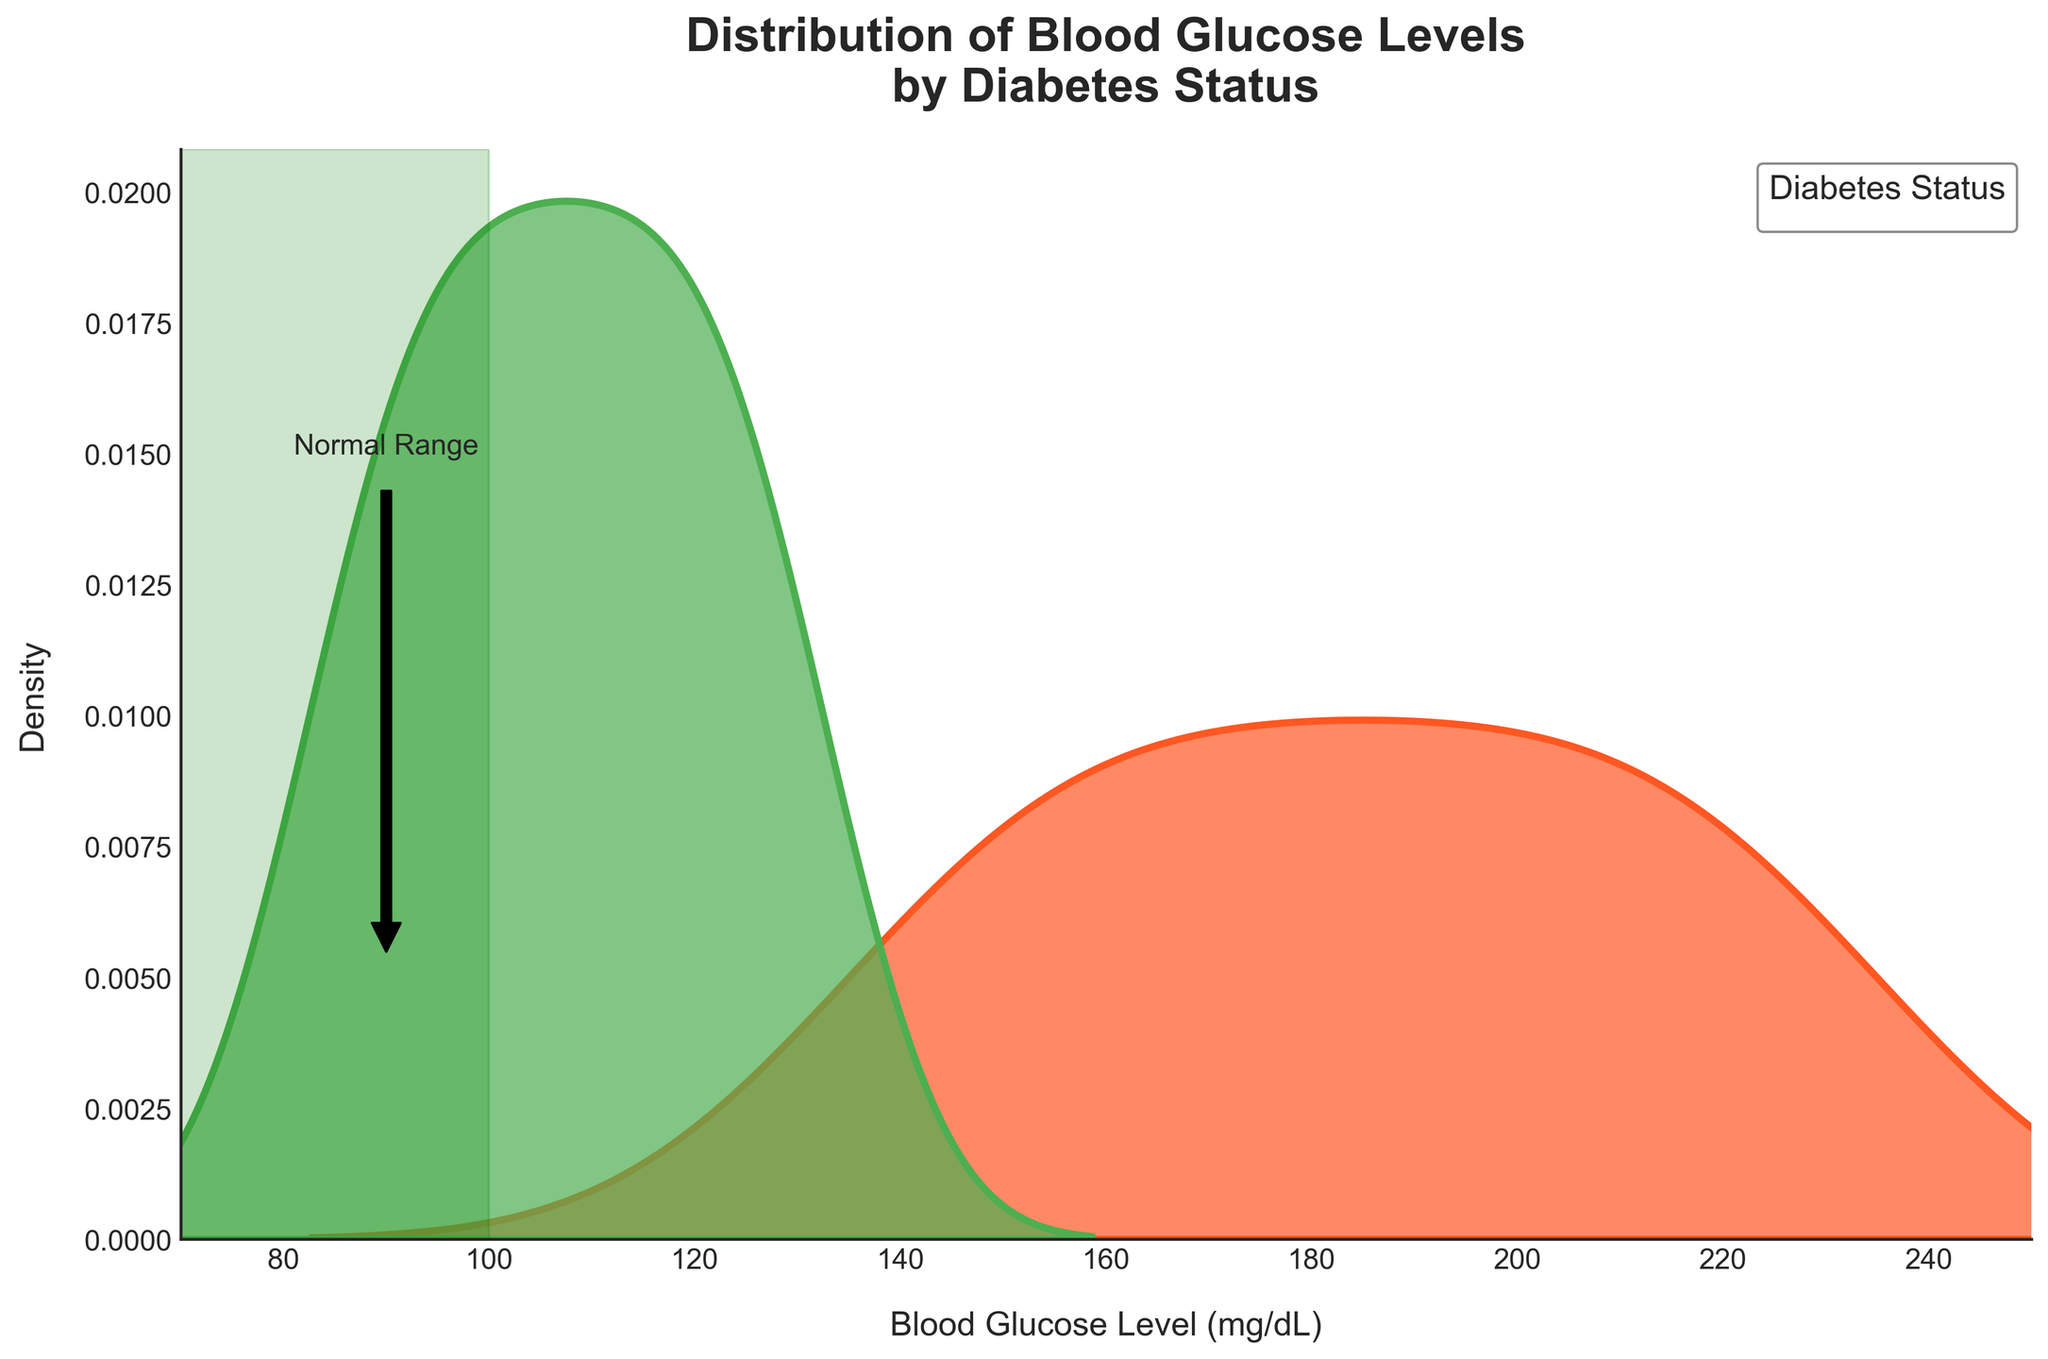What does the title of the plot indicate? The title of the plot, "Distribution of Blood Glucose Levels by Diabetes Status," suggests that the plot shows how blood glucose levels are distributed for patients who are diabetic and those who are non-diabetic.
Answer: Distribution of Blood Glucose Levels by Diabetes Status What are the two colors used to differentiate the groups, and what do they represent? The two colors used in the plot are green and orange. Green represents non-diabetic patients, while orange represents diabetic patients.
Answer: Green for non-diabetic, orange for diabetic What is the label of the x-axis, and what does it represent? The x-axis label is "Blood Glucose Level (mg/dL)," which represents the blood glucose levels measured in milligrams per deciliter for each patient.
Answer: Blood Glucose Level (mg/dL) Which group shows a higher overall density of blood glucose levels around 200 mg/dL? By observing the plot, it is clear that the diabetic group (represented in orange) shows a higher density of blood glucose levels around 200 mg/dL compared to the non-diabetic group.
Answer: Diabetic In which range of blood glucose levels have the non-diabetic patients been highlighted with a shaded area? The shaded area representing the range for non-diabetic patients is 70 to 100 mg/dL, shown in light green. This highlights the normal range for non-diabetic patients.
Answer: 70 to 100 mg/dL Where is the "Normal Range" annotation placed, and what does it indicate? The "Normal Range" annotation is placed around the blood glucose level of 90 mg/dL on the x-axis. It indicates the range that is considered normal for non-diabetic patients.
Answer: Around 90 mg/dL Do non-diabetic patients have blood glucose levels higher than 130 mg/dL? According to the plot, non-diabetic patients do not have blood glucose levels higher than 130 mg/dL as the green density curve declines rapidly after 130 mg/dL.
Answer: No How does the density curve for diabetic patients compare to non-diabetic patients between 70 to 100 mg/dL? The density curve for diabetic patients (orange) is very low between 70 to 100 mg/dL compared to non-diabetic patients (green), indicating that fewer diabetic patients have blood glucose levels in this normal range.
Answer: Lower for diabetic patients At what approximate blood glucose level do the density curves of diabetic and non-diabetic patients intersect? The density curves of diabetic and non-diabetic patients intersect around a blood glucose level of approximately 125 mg/dL, where the green and orange lines cross.
Answer: 125 mg/dL What does the arrow pointing towards the "Normal Range" annotation signify? The arrow pointing towards the "Normal Range" annotation signifies that blood glucose levels around 90 mg/dL are considered to be within the normal range for non-diabetic patients.
Answer: Normal range around 90 mg/dL 